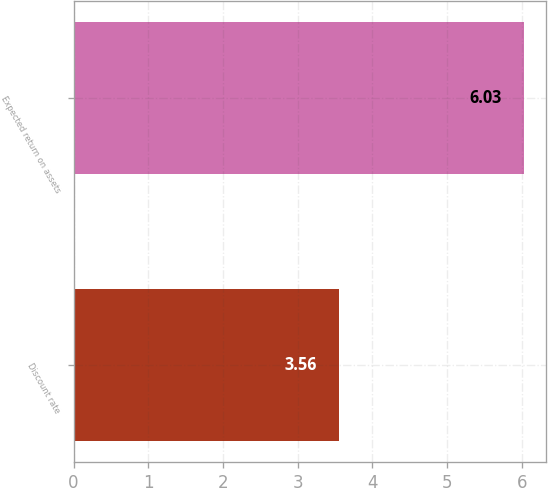Convert chart. <chart><loc_0><loc_0><loc_500><loc_500><bar_chart><fcel>Discount rate<fcel>Expected return on assets<nl><fcel>3.56<fcel>6.03<nl></chart> 